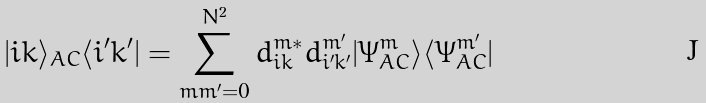<formula> <loc_0><loc_0><loc_500><loc_500>| i k \rangle _ { A C } \langle i ^ { \prime } k ^ { \prime } | = \sum _ { m m ^ { \prime } = 0 } ^ { N ^ { 2 } } d ^ { m * } _ { i k } d ^ { m ^ { \prime } } _ { i ^ { \prime } k ^ { \prime } } | \Psi _ { A C } ^ { m } \rangle \langle \Psi _ { A C } ^ { m ^ { \prime } } |</formula> 